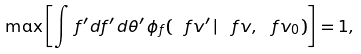Convert formula to latex. <formula><loc_0><loc_0><loc_500><loc_500>\max \left [ \int \, f ^ { \prime } d f ^ { \prime } \, d \theta ^ { \prime } \, \phi _ { f } ( \ f v ^ { \prime } \, | \, \ f v , \ f v _ { 0 } ) \right ] = 1 ,</formula> 